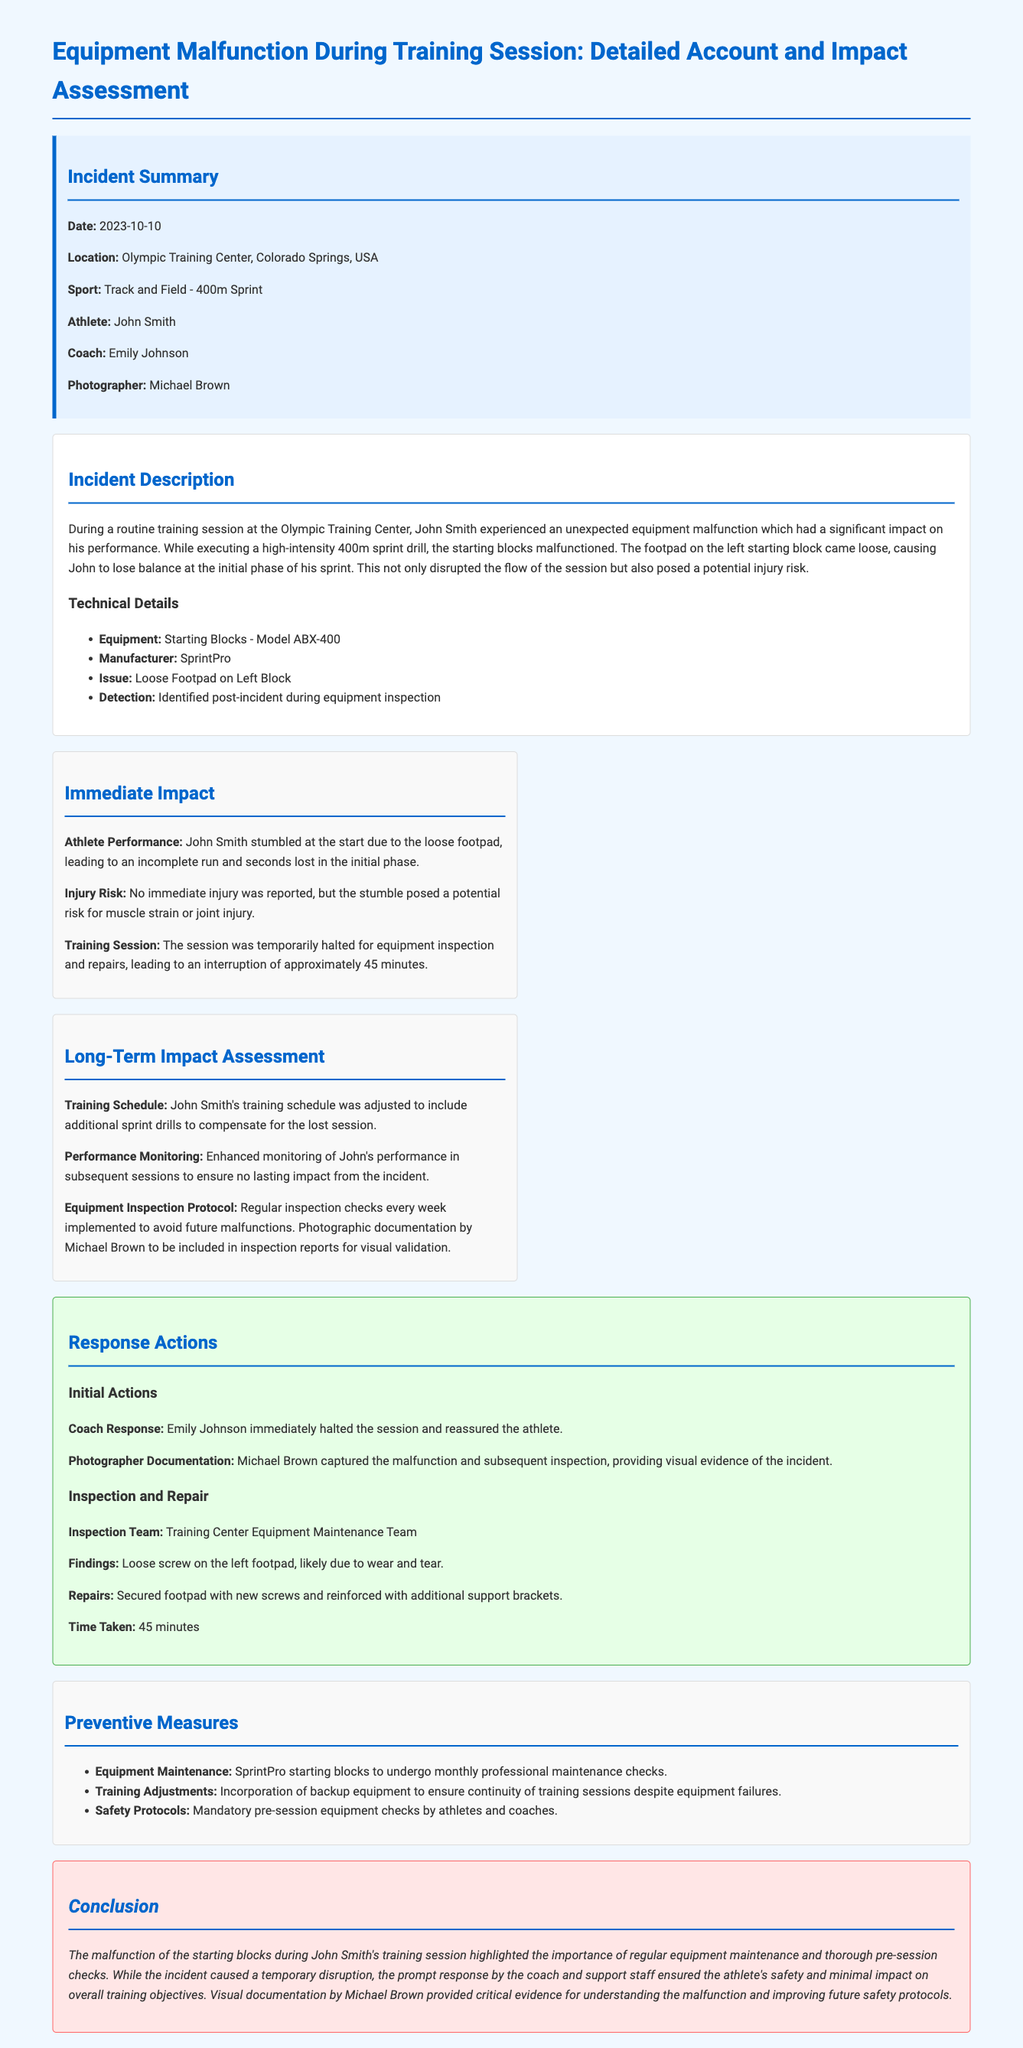What sport was involved in the incident? The sport involved in the incident is specified in the incident summary section.
Answer: Track and Field - 400m Sprint Who was the athlete experiencing the equipment malfunction? The athlete's name is mentioned in the incident summary section.
Answer: John Smith What was the date of the incident? The date of the incident is provided in the incident summary section.
Answer: 2023-10-10 What type of equipment malfunctioned? The type of equipment that malfunctioned is detailed in the incident description.
Answer: Starting Blocks What immediate impact was recorded regarding athlete performance? The immediate impact on athlete performance can be found in the impact assessment section.
Answer: John Smith stumbled at the start How long was the training session interrupted due to the incident? The duration of the training session interruption is mentioned in the immediate impact assessment.
Answer: 45 minutes What measures were proposed for equipment maintenance? The preventive measure regarding equipment maintenance is specified in the preventive measures section.
Answer: Monthly professional maintenance checks What was captured by the photographer during the incident? The actions of the photographer are described in the response actions section.
Answer: Malfunction and subsequent inspection Who was the coach present during the incident? The coach's name is listed in the incident summary section.
Answer: Emily Johnson 